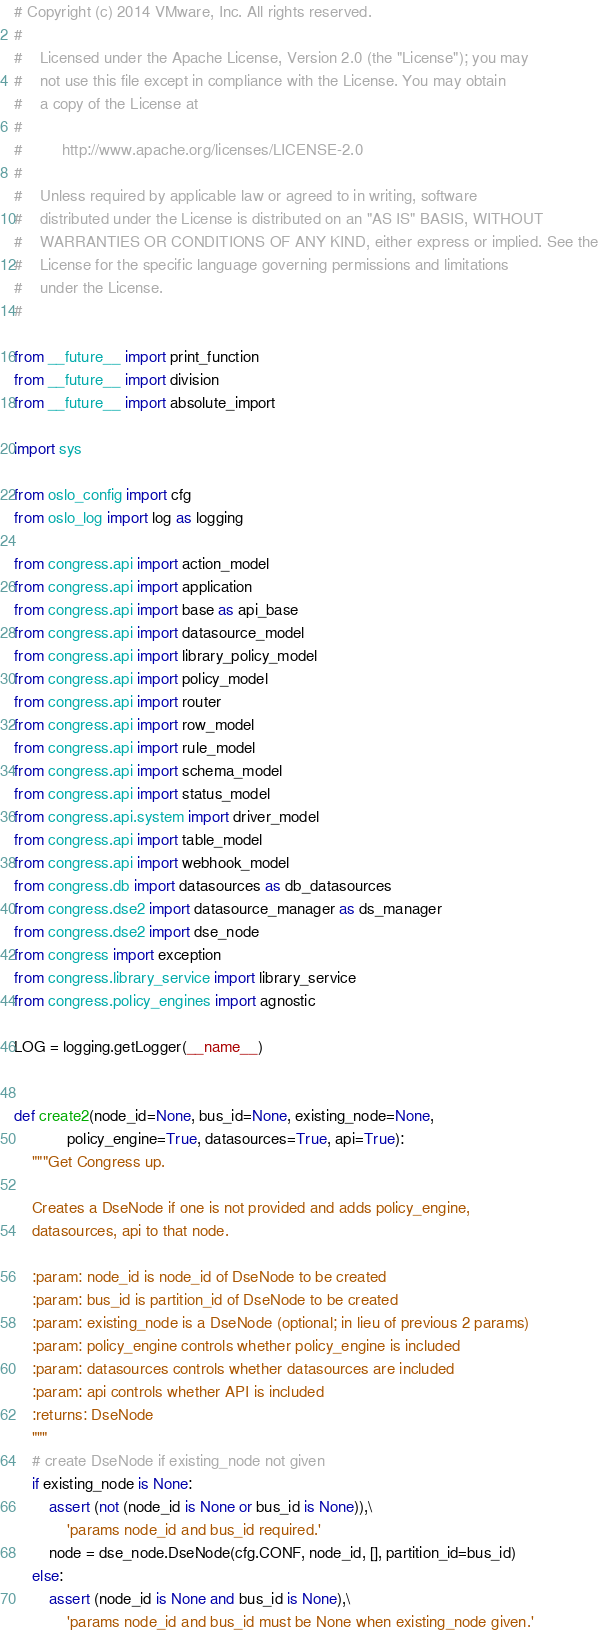Convert code to text. <code><loc_0><loc_0><loc_500><loc_500><_Python_># Copyright (c) 2014 VMware, Inc. All rights reserved.
#
#    Licensed under the Apache License, Version 2.0 (the "License"); you may
#    not use this file except in compliance with the License. You may obtain
#    a copy of the License at
#
#         http://www.apache.org/licenses/LICENSE-2.0
#
#    Unless required by applicable law or agreed to in writing, software
#    distributed under the License is distributed on an "AS IS" BASIS, WITHOUT
#    WARRANTIES OR CONDITIONS OF ANY KIND, either express or implied. See the
#    License for the specific language governing permissions and limitations
#    under the License.
#

from __future__ import print_function
from __future__ import division
from __future__ import absolute_import

import sys

from oslo_config import cfg
from oslo_log import log as logging

from congress.api import action_model
from congress.api import application
from congress.api import base as api_base
from congress.api import datasource_model
from congress.api import library_policy_model
from congress.api import policy_model
from congress.api import router
from congress.api import row_model
from congress.api import rule_model
from congress.api import schema_model
from congress.api import status_model
from congress.api.system import driver_model
from congress.api import table_model
from congress.api import webhook_model
from congress.db import datasources as db_datasources
from congress.dse2 import datasource_manager as ds_manager
from congress.dse2 import dse_node
from congress import exception
from congress.library_service import library_service
from congress.policy_engines import agnostic

LOG = logging.getLogger(__name__)


def create2(node_id=None, bus_id=None, existing_node=None,
            policy_engine=True, datasources=True, api=True):
    """Get Congress up.

    Creates a DseNode if one is not provided and adds policy_engine,
    datasources, api to that node.

    :param: node_id is node_id of DseNode to be created
    :param: bus_id is partition_id of DseNode to be created
    :param: existing_node is a DseNode (optional; in lieu of previous 2 params)
    :param: policy_engine controls whether policy_engine is included
    :param: datasources controls whether datasources are included
    :param: api controls whether API is included
    :returns: DseNode
    """
    # create DseNode if existing_node not given
    if existing_node is None:
        assert (not (node_id is None or bus_id is None)),\
            'params node_id and bus_id required.'
        node = dse_node.DseNode(cfg.CONF, node_id, [], partition_id=bus_id)
    else:
        assert (node_id is None and bus_id is None),\
            'params node_id and bus_id must be None when existing_node given.'</code> 